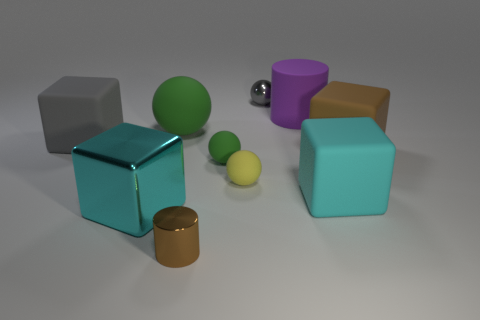Does the matte cube that is on the left side of the purple rubber object have the same color as the tiny metallic sphere? While both objects reflect light differently due to their respective matte and metallic finishes, the matte cube on the left side of the purple rubber object does indeed share the same basic hue as the tiny metallic sphere. Their shared color appears to be a shade of grey, confirming that they have the same color in terms of hue. 